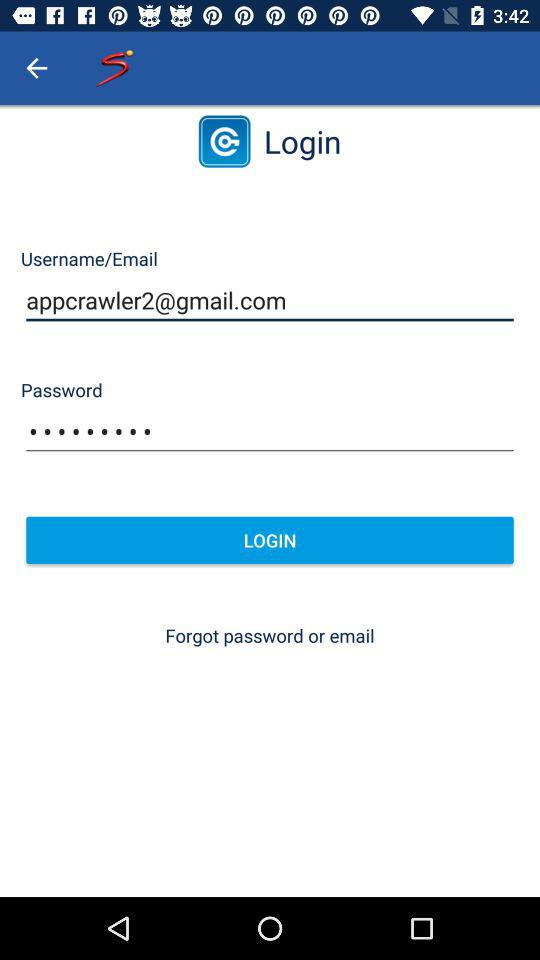What is the email address? The email address is appcrawler2@gmail.com. 